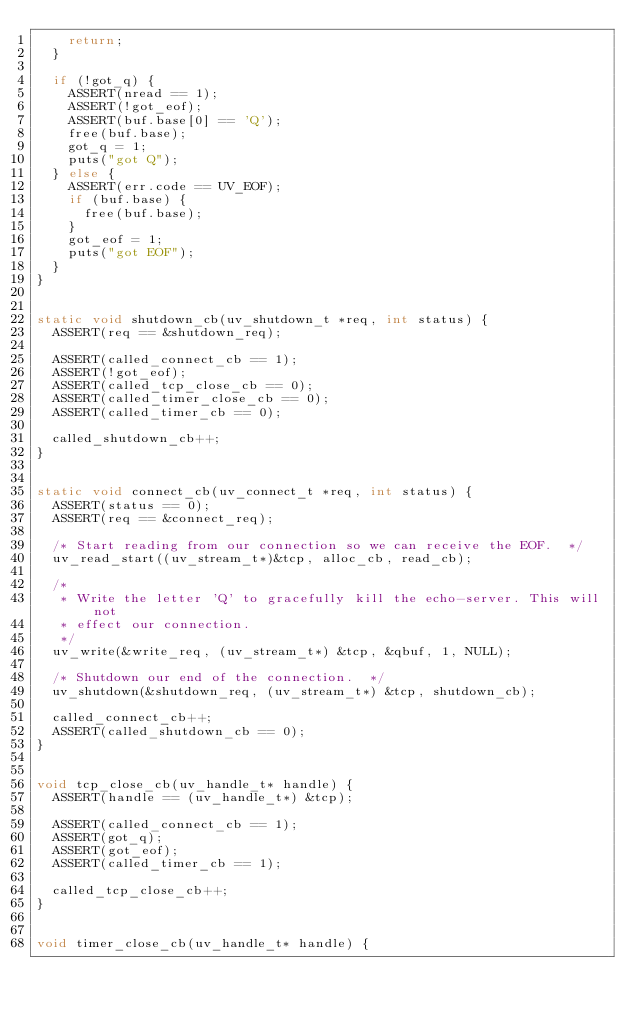Convert code to text. <code><loc_0><loc_0><loc_500><loc_500><_C_>    return;
  }

  if (!got_q) {
    ASSERT(nread == 1);
    ASSERT(!got_eof);
    ASSERT(buf.base[0] == 'Q');
    free(buf.base);
    got_q = 1;
    puts("got Q");
  } else {
    ASSERT(err.code == UV_EOF);
    if (buf.base) {
      free(buf.base);
    }
    got_eof = 1;
    puts("got EOF");
  }
}


static void shutdown_cb(uv_shutdown_t *req, int status) {
  ASSERT(req == &shutdown_req);

  ASSERT(called_connect_cb == 1);
  ASSERT(!got_eof);
  ASSERT(called_tcp_close_cb == 0);
  ASSERT(called_timer_close_cb == 0);
  ASSERT(called_timer_cb == 0);

  called_shutdown_cb++;
}


static void connect_cb(uv_connect_t *req, int status) {
  ASSERT(status == 0);
  ASSERT(req == &connect_req);

  /* Start reading from our connection so we can receive the EOF.  */
  uv_read_start((uv_stream_t*)&tcp, alloc_cb, read_cb);

  /*
   * Write the letter 'Q' to gracefully kill the echo-server. This will not
   * effect our connection.
   */
  uv_write(&write_req, (uv_stream_t*) &tcp, &qbuf, 1, NULL);

  /* Shutdown our end of the connection.  */
  uv_shutdown(&shutdown_req, (uv_stream_t*) &tcp, shutdown_cb);

  called_connect_cb++;
  ASSERT(called_shutdown_cb == 0);
}


void tcp_close_cb(uv_handle_t* handle) {
  ASSERT(handle == (uv_handle_t*) &tcp);

  ASSERT(called_connect_cb == 1);
  ASSERT(got_q);
  ASSERT(got_eof);
  ASSERT(called_timer_cb == 1);

  called_tcp_close_cb++;
}


void timer_close_cb(uv_handle_t* handle) {</code> 